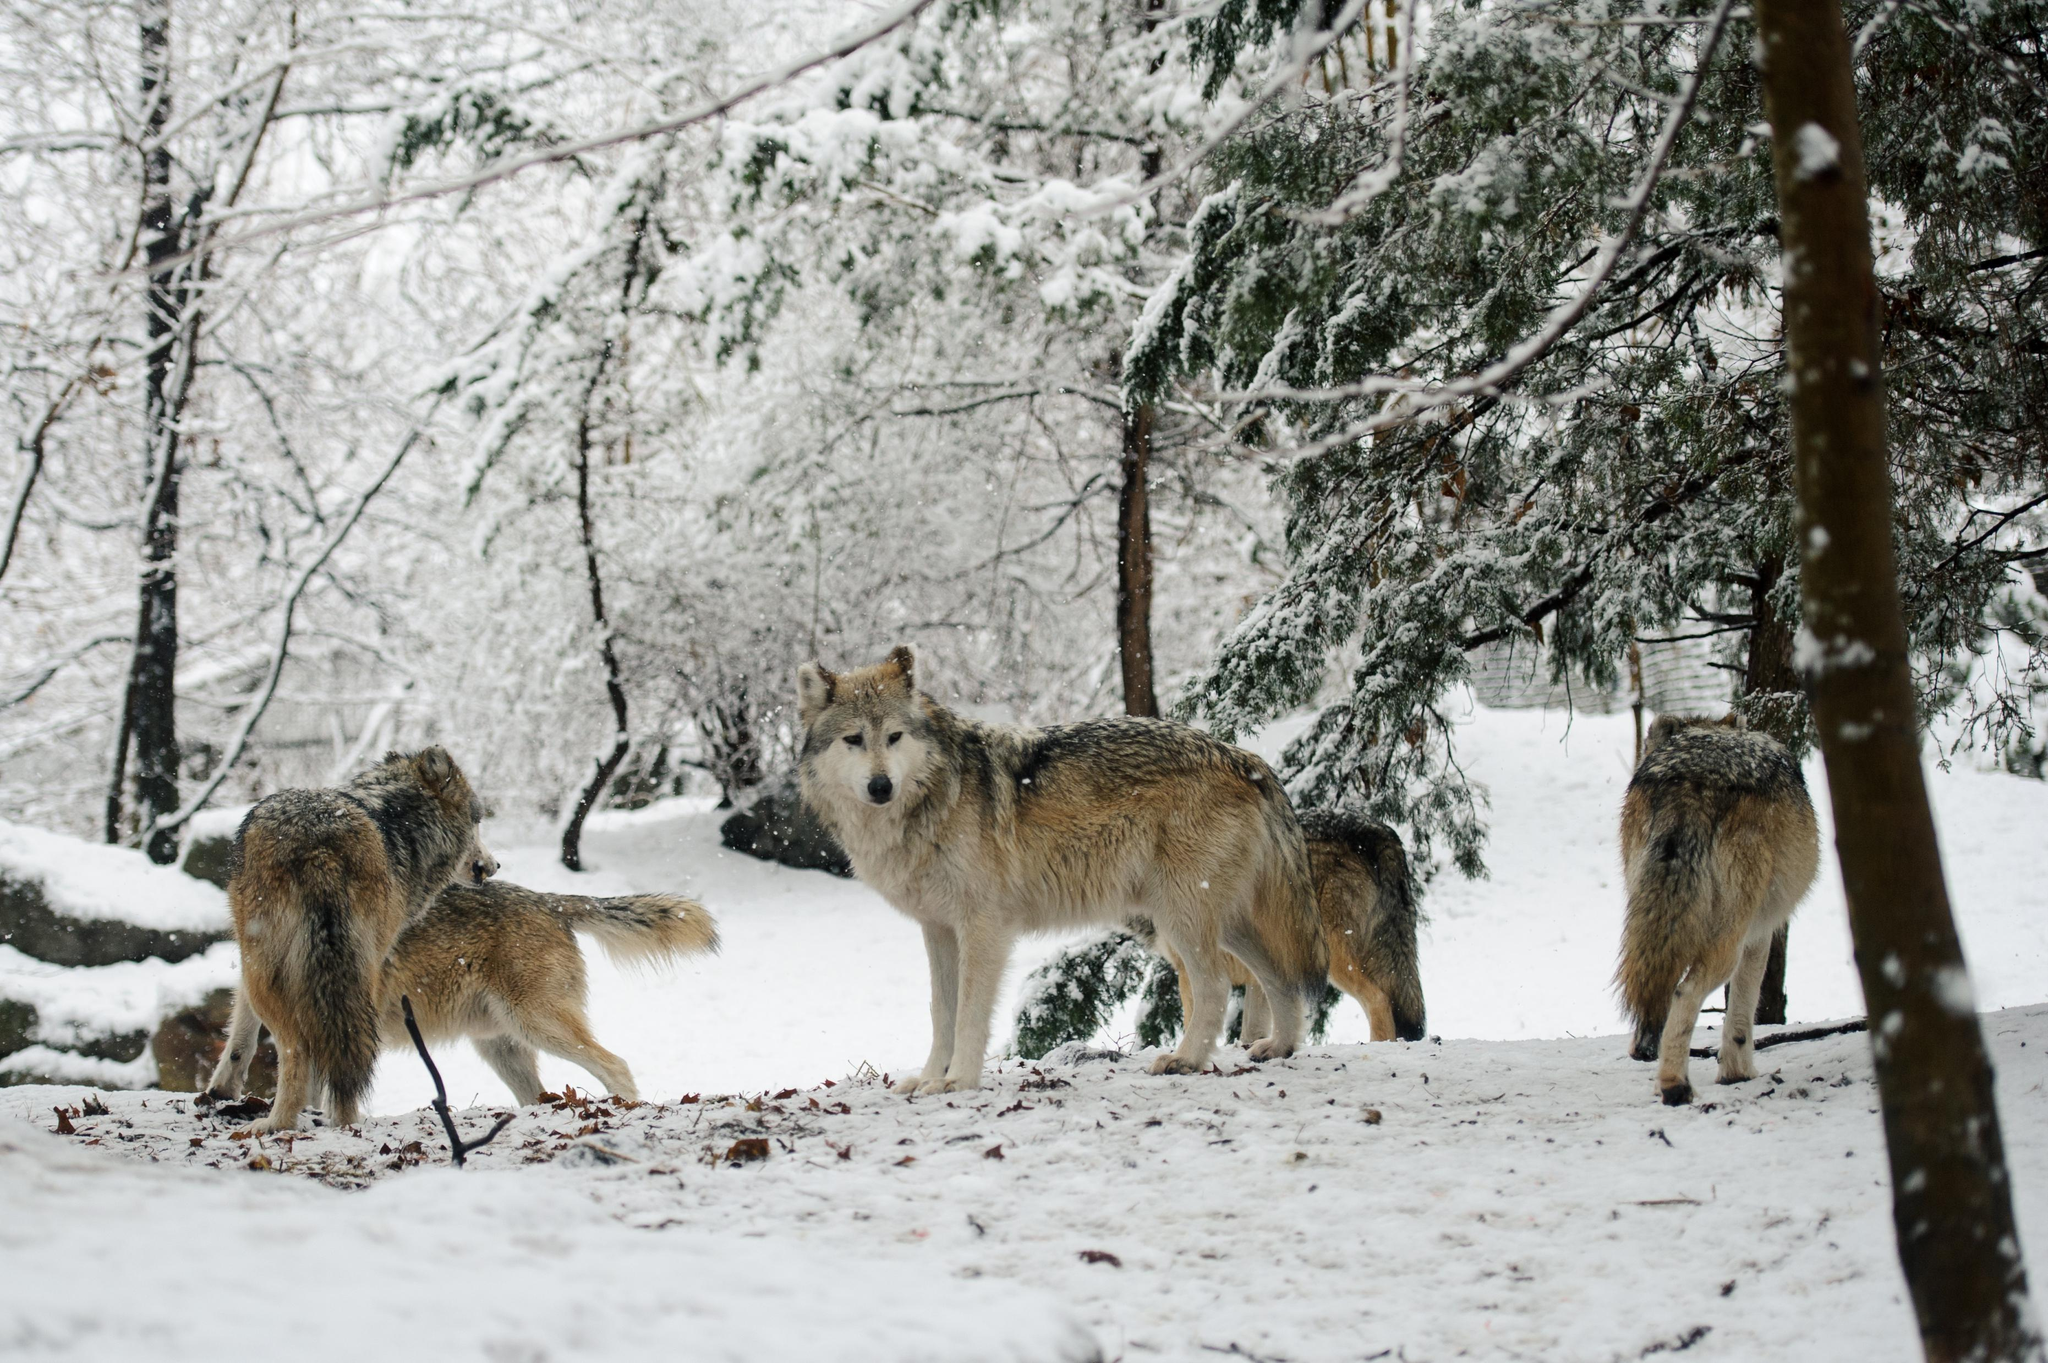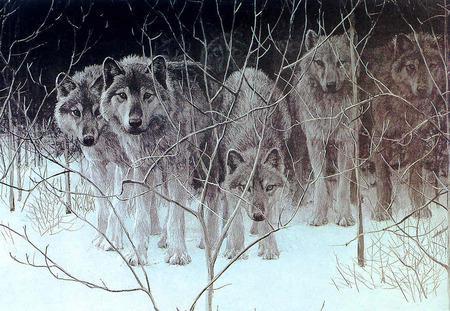The first image is the image on the left, the second image is the image on the right. Examine the images to the left and right. Is the description "Wolves are walking leftward in a straight line across snow-covered ground in one image." accurate? Answer yes or no. No. The first image is the image on the left, the second image is the image on the right. Evaluate the accuracy of this statement regarding the images: "The right image contains exactly one wolf.". Is it true? Answer yes or no. No. 